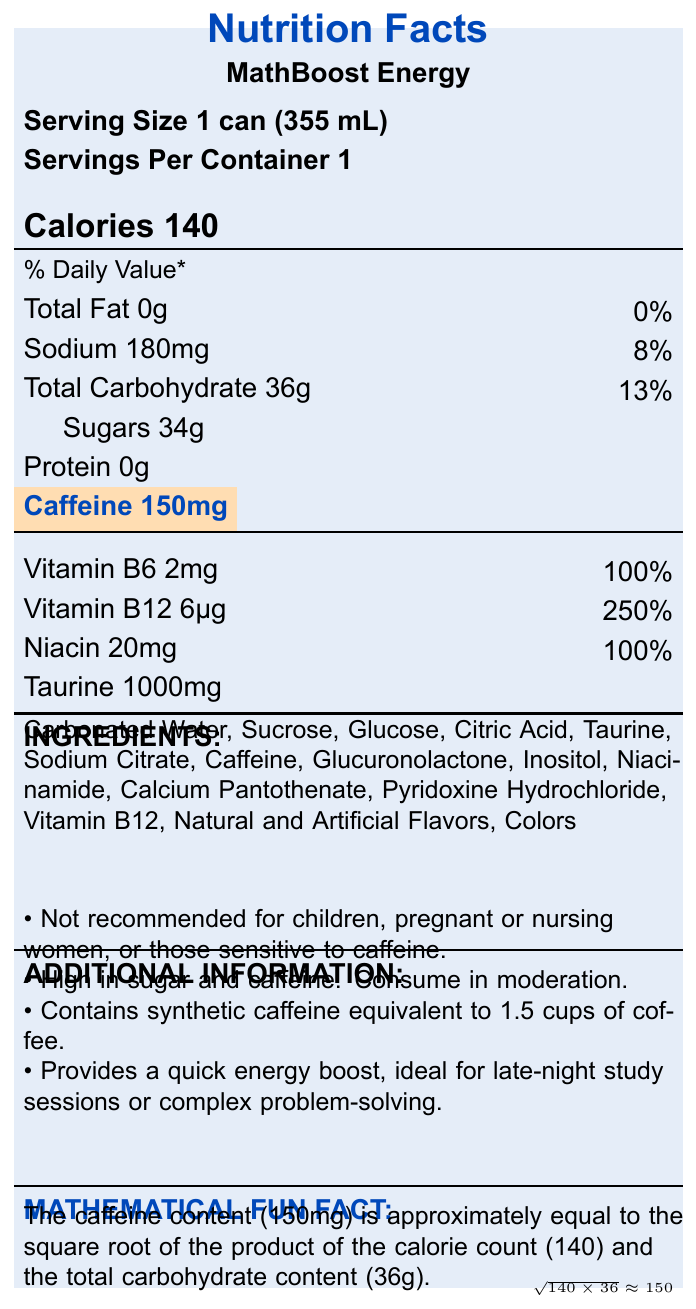what is the serving size for MathBoost Energy? The serving size is explicitly stated in the document as "Serving Size 1 can (355 mL)."
Answer: 1 can (355 mL) how many calories are in one serving of MathBoost Energy? The document states "Calories 140" which refers to the calorie content per serving.
Answer: 140 what is the total carbohydrate content per serving? The document states "Total Carbohydrate 36g" which refers to the carbohydrate content per serving.
Answer: 36g how much sodium does one serving contain? The document states "Sodium 180mg" which refers to the sodium content per serving.
Answer: 180mg how much Vitamin B6 is in a serving of MathBoost Energy? The document lists "Vitamin B6 2mg" under the vitamins and minerals section.
Answer: 2mg what percentage of the daily value for Vitamin B12 is provided by one serving? The document states "Vitamin B12 6μg" with a daily value of "250%" in the vitamins and minerals section.
Answer: 250% which of the following ingredients are in MathBoost Energy? (A) Carbonated Water, (B) Sucrose, (C) Caffeine, (D) All of the above All mentioned ingredients (Carbonated Water, Sucrose, Caffeine) are listed under the ingredients section in the document.
Answer: D what is the daily value percentage for total fat in MathBoost Energy? (i) 0%, (ii) 8%, (iii) 13%, (iv) 100% The document states "Total Fat 0g" with a daily value of "0%".
Answer: i True or False: MathBoost Energy is recommended for children. The additional information section clearly states "Not recommended for children".
Answer: False what is highlighted in the document, and why? The caffeine content (150mg) is highlighted, possibly because it's a significant feature or for cautionary reasons as it's explicitly mentioned in the additional information and has health implications.
Answer: Caffeine content is highlighted. what is a mathematical fun fact mentioned in the document? The document lists this fun fact: "The caffeine content (150mg) is approximately equal to the square root of the product of the calorie count (140) and the total carbohydrate content (36g)."
Answer: The caffeine content (150mg) is approximately equal to the square root of the product of the calorie count (140) and the total carbohydrate content (36g). how much sugar does MathBoost Energy contain? The document states "Sugars 34g" under the total carbohydrate section.
Answer: 34g summarize the main idea of the document. The document provides detailed nutrition facts, including calorie content, macronutrients, and vitamins, highlights caffeine content, lists ingredients, gives additional consumption advice, and includes a mathematical fun fact related to its nutritional values.
Answer: MathBoost Energy is an energy drink with specific nutrition information including high caffeine and sugar content, appropriate mainly for adults needing an energy boost. what is the exact amount of natural flavors in MathBoost Energy? The document lists "Natural and Artificial Flavors" as an ingredient but does not provide the exact amount.
Answer: Cannot be determined 